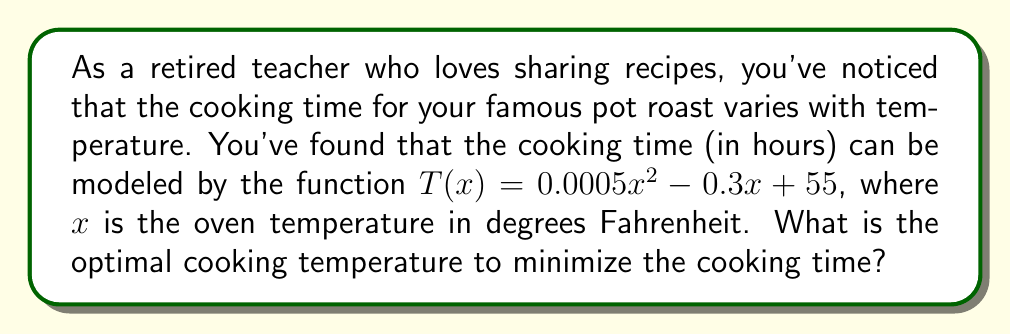Show me your answer to this math problem. To find the optimal cooking temperature, we need to determine the minimum point of the function $T(x)$. This can be done using derivatives:

1) First, find the derivative of $T(x)$:
   $$T'(x) = 0.001x - 0.3$$

2) To find the minimum point, set $T'(x) = 0$ and solve for $x$:
   $$0.001x - 0.3 = 0$$
   $$0.001x = 0.3$$
   $$x = 300$$

3) To confirm this is a minimum (not a maximum), check the second derivative:
   $$T''(x) = 0.001$$
   Since $T''(x) > 0$, the critical point is indeed a minimum.

4) Therefore, the optimal cooking temperature is 300°F.

5) To find the minimum cooking time, substitute $x = 300$ into the original function:
   $$T(300) = 0.0005(300)^2 - 0.3(300) + 55$$
   $$= 45 - 90 + 55 = 10$$

So, the minimum cooking time is 10 hours at 300°F.
Answer: 300°F 